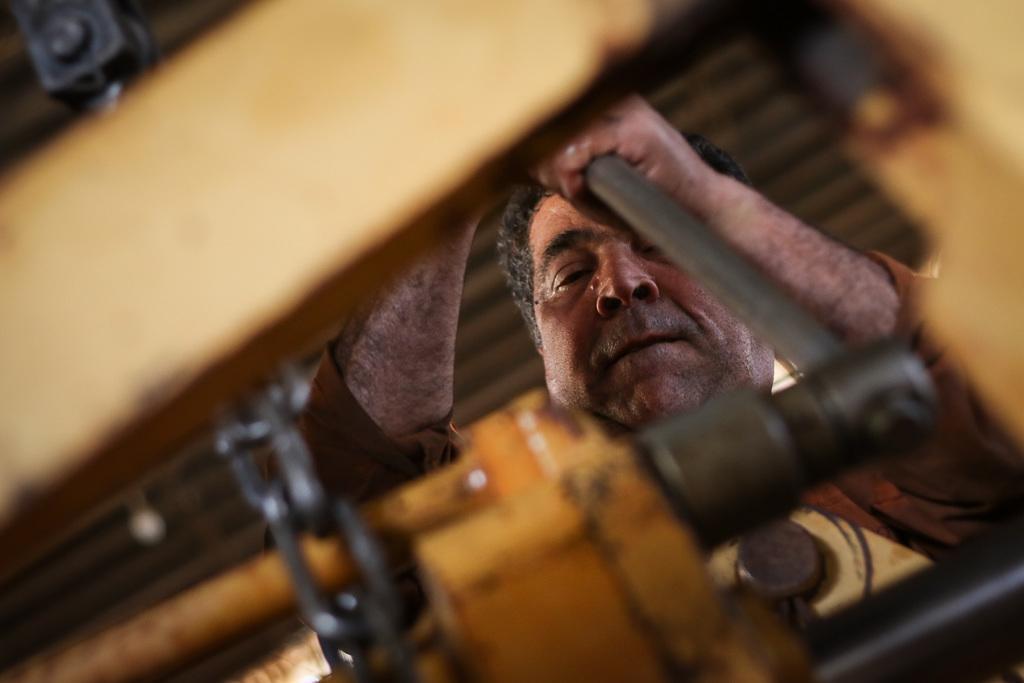Describe this image in one or two sentences. In this image we can see a person holding an object. There are few metallic objects in the image. 